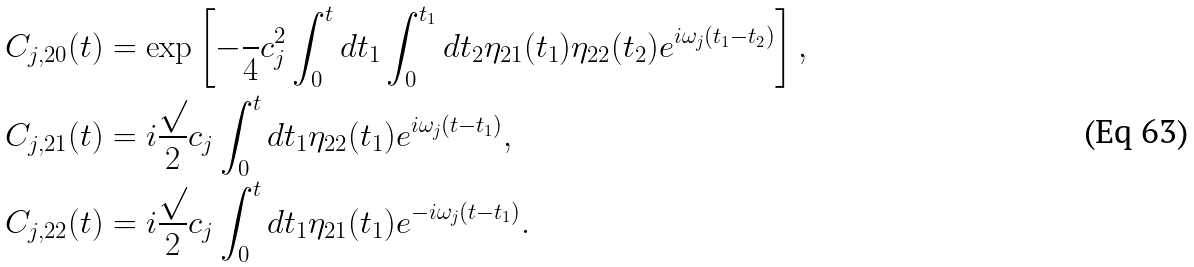<formula> <loc_0><loc_0><loc_500><loc_500>C _ { j , 2 0 } ( t ) & = \exp \left [ - \frac { } { 4 } c ^ { 2 } _ { j } \int _ { 0 } ^ { t } d t _ { 1 } \int _ { 0 } ^ { t _ { 1 } } d t _ { 2 } \eta _ { 2 1 } ( t _ { 1 } ) \eta _ { 2 2 } ( t _ { 2 } ) e ^ { i \omega _ { j } ( t _ { 1 } - t _ { 2 } ) } \right ] , \\ C _ { j , 2 1 } ( t ) & = i \frac { \sqrt { } } { 2 } c _ { j } \int _ { 0 } ^ { t } d t _ { 1 } \eta _ { 2 2 } ( t _ { 1 } ) e ^ { i \omega _ { j } ( t - t _ { 1 } ) } , \\ C _ { j , 2 2 } ( t ) & = i \frac { \sqrt { } } { 2 } c _ { j } \int _ { 0 } ^ { t } d t _ { 1 } \eta _ { 2 1 } ( t _ { 1 } ) e ^ { - i \omega _ { j } ( t - t _ { 1 } ) } .</formula> 